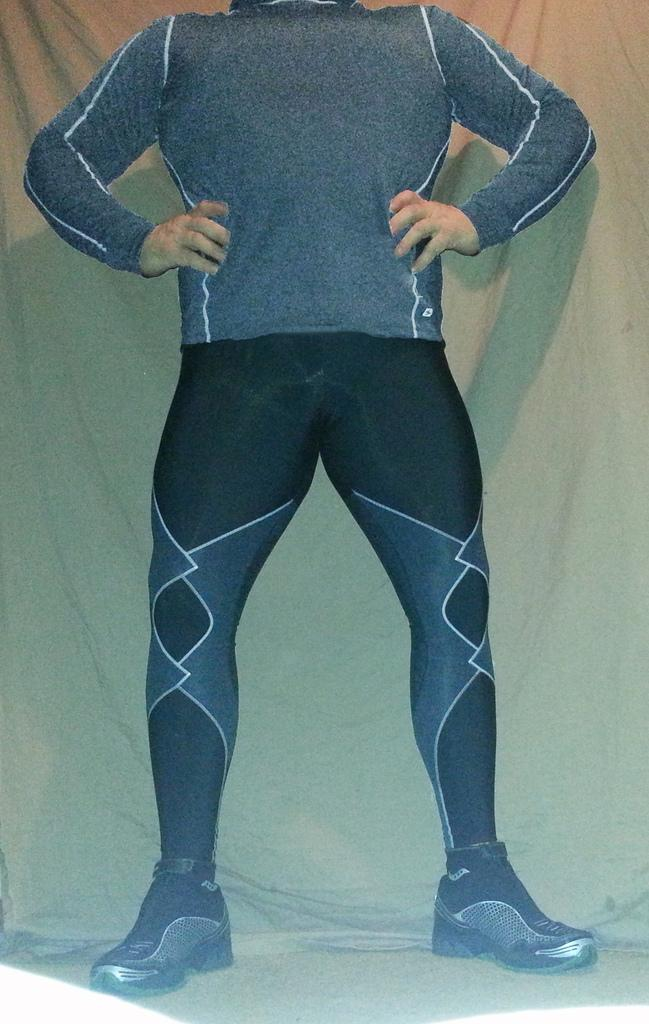What is the main subject of the image? There is a person standing in the image. Can you describe the background of the image? The background appears to be made of cloth. What type of exchange is taking place in the image? There is no exchange taking place in the image; it only shows a person standing in front of a cloth background. Can you see a train in the image? There is no train present in the image. 